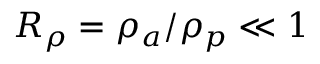<formula> <loc_0><loc_0><loc_500><loc_500>R _ { \rho } = \rho _ { a } / \rho _ { p } \ll 1</formula> 